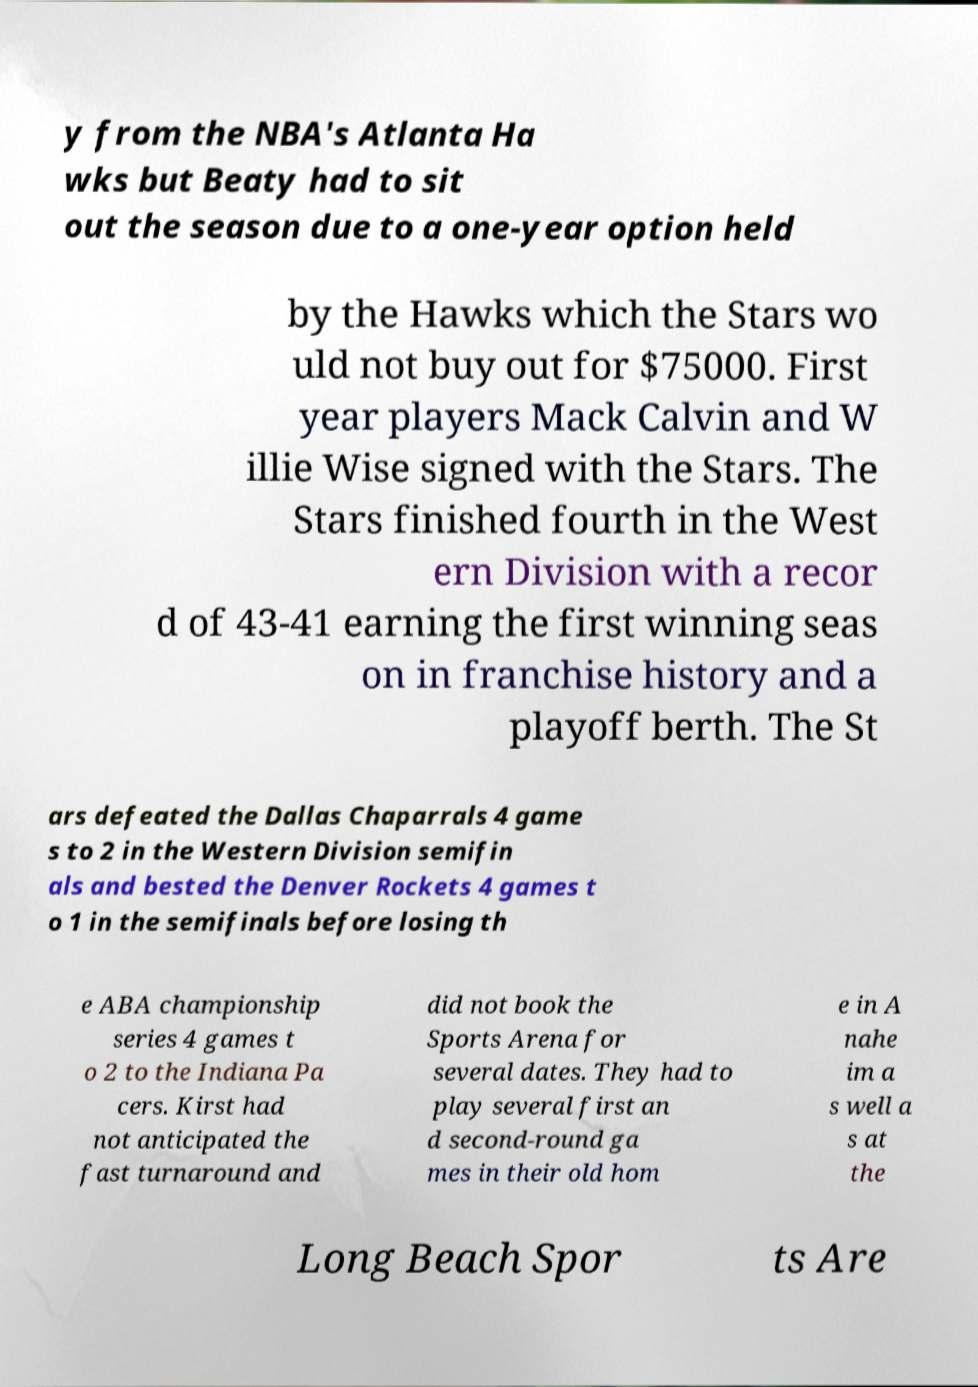I need the written content from this picture converted into text. Can you do that? y from the NBA's Atlanta Ha wks but Beaty had to sit out the season due to a one-year option held by the Hawks which the Stars wo uld not buy out for $75000. First year players Mack Calvin and W illie Wise signed with the Stars. The Stars finished fourth in the West ern Division with a recor d of 43-41 earning the first winning seas on in franchise history and a playoff berth. The St ars defeated the Dallas Chaparrals 4 game s to 2 in the Western Division semifin als and bested the Denver Rockets 4 games t o 1 in the semifinals before losing th e ABA championship series 4 games t o 2 to the Indiana Pa cers. Kirst had not anticipated the fast turnaround and did not book the Sports Arena for several dates. They had to play several first an d second-round ga mes in their old hom e in A nahe im a s well a s at the Long Beach Spor ts Are 